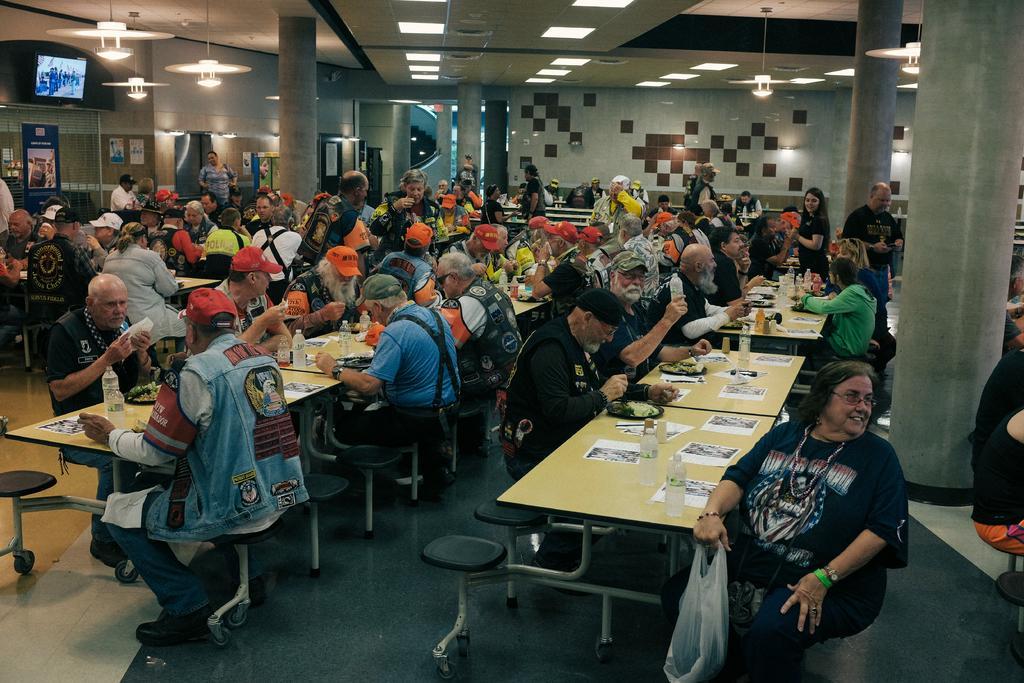Can you describe this image briefly? In this picture group of people sitting on the chair. Few people standing. We can see chairs and tables. On the table we can see paper,bottle,plate,food. On the background we can see wall and pillars. On the top we can see lights. This is television. 